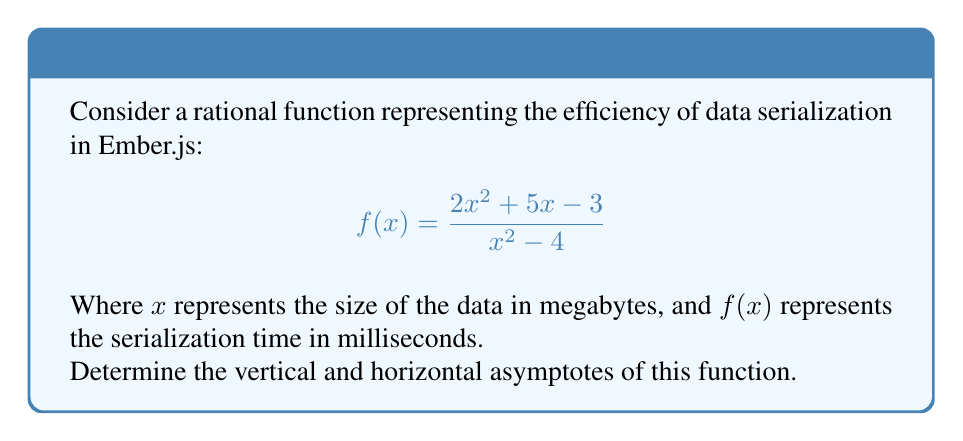Can you solve this math problem? To find the asymptotes of this rational function, we'll follow these steps:

1. Vertical Asymptotes:
   Vertical asymptotes occur when the denominator equals zero.
   Set the denominator to zero and solve:
   $$x^2 - 4 = 0$$
   $$(x+2)(x-2) = 0$$
   $$x = -2 \text{ or } x = 2$$
   Therefore, vertical asymptotes occur at $x = -2$ and $x = 2$.

2. Horizontal Asymptote:
   To find the horizontal asymptote, we compare the degrees of the numerator and denominator.
   
   Degree of numerator: 2
   Degree of denominator: 2
   
   When the degrees are equal, the horizontal asymptote is the ratio of the leading coefficients:
   
   $$y = \frac{\text{leading coefficient of numerator}}{\text{leading coefficient of denominator}} = \frac{2}{1} = 2$$

   Therefore, the horizontal asymptote is $y = 2$.

3. Slant Asymptotes:
   Since the degree of the numerator is not greater than the degree of the denominator, there are no slant asymptotes.
Answer: Vertical asymptotes: $x = -2, x = 2$; Horizontal asymptote: $y = 2$ 